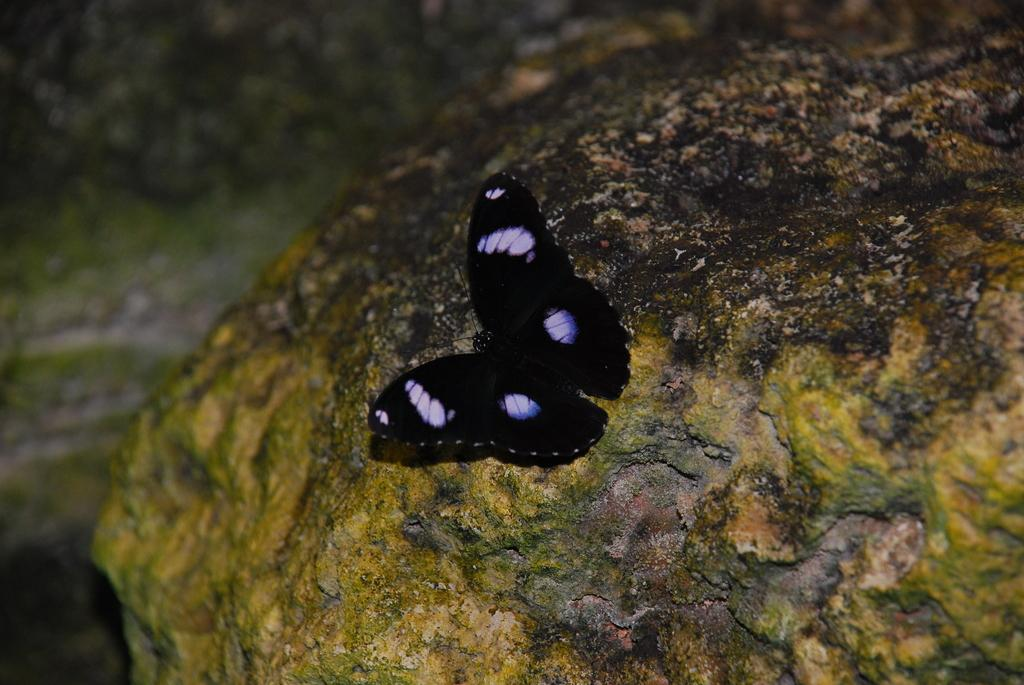What is the main subject of the image? There is a butterfly in the image. Where is the butterfly located? The butterfly is on a rock. What type of vein is visible on the beetle in the image? There is no beetle present in the image, only a butterfly. 